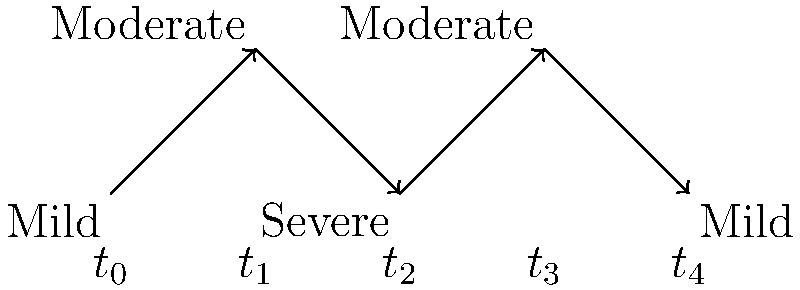In the directed graph above, which represents the progression of a mental health disorder over time, what does the path from $t_0$ to $t_4$ suggest about the course of the disorder? How might this information inform treatment strategies? To analyze the progression of the mental health disorder and its implications for treatment:

1. Observe the initial state: At $t_0$, the disorder is classified as "Mild".

2. Track the progression:
   - $t_0$ to $t_1$: Mild to Moderate (worsening)
   - $t_1$ to $t_2$: Moderate to Severe (further worsening)
   - $t_2$ to $t_3$: Severe to Moderate (improvement)
   - $t_3$ to $t_4$: Moderate to Mild (further improvement)

3. Identify the pattern: The disorder initially worsens, reaches a peak severity, and then improves back to the initial mild state.

4. Interpret the course: This pattern suggests a disorder with acute exacerbation followed by remission, possibly responding to treatment or natural course.

5. Treatment implications:
   a) Early intervention: Aggressive treatment may be needed when symptoms worsen from mild to moderate.
   b) Crisis management: Prepare for potential severe phase and have strategies in place.
   c) Maintenance therapy: Continue treatment even as symptoms improve to prevent relapse.
   d) Long-term monitoring: Regular follow-ups to track progression and adjust treatment accordingly.

6. Research implications: This pattern could inform studies on:
   - Factors triggering exacerbation
   - Effectiveness of interventions at different severity levels
   - Predictors of remission

7. Patient education: Use this model to explain the potential course of the disorder, set expectations, and emphasize the importance of consistent treatment.
Answer: The graph shows an acute exacerbation followed by remission, suggesting the need for early intervention, crisis management, maintenance therapy, and long-term monitoring in treatment planning. 